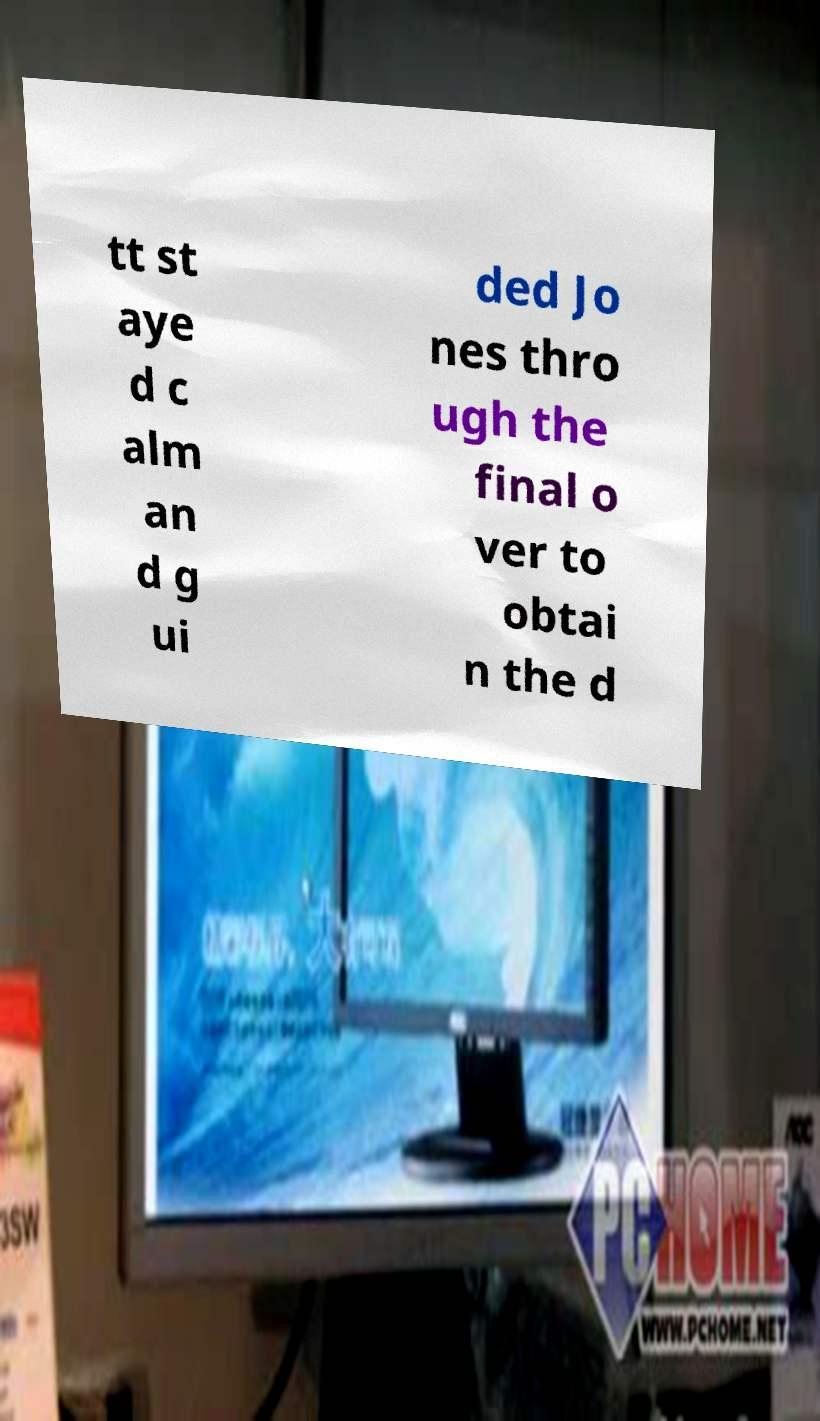Please read and relay the text visible in this image. What does it say? tt st aye d c alm an d g ui ded Jo nes thro ugh the final o ver to obtai n the d 